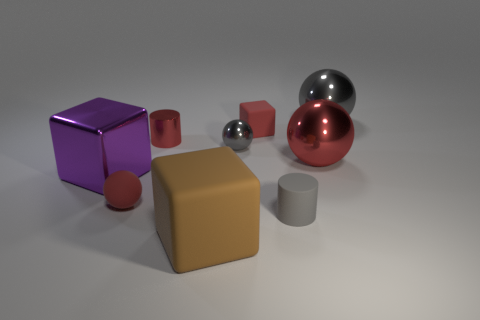Is the number of big things that are to the left of the brown rubber block the same as the number of large purple things in front of the small block?
Your answer should be compact. Yes. There is a large brown matte object; is its shape the same as the gray metal thing that is to the right of the large red metal sphere?
Your answer should be very brief. No. What material is the big thing that is the same color as the matte ball?
Ensure brevity in your answer.  Metal. Are there any other things that are the same shape as the large red object?
Offer a very short reply. Yes. Is the material of the purple cube the same as the red ball that is right of the big brown cube?
Offer a very short reply. Yes. What is the color of the matte cube to the left of the gray sphere in front of the small cylinder left of the gray matte cylinder?
Your response must be concise. Brown. There is a small matte cylinder; is its color the same as the tiny sphere that is on the right side of the big brown rubber cube?
Offer a terse response. Yes. What is the color of the small block?
Provide a short and direct response. Red. The small gray matte object that is in front of the large purple block that is behind the cube in front of the big purple block is what shape?
Offer a very short reply. Cylinder. What number of other objects are the same color as the tiny shiny sphere?
Ensure brevity in your answer.  2. 